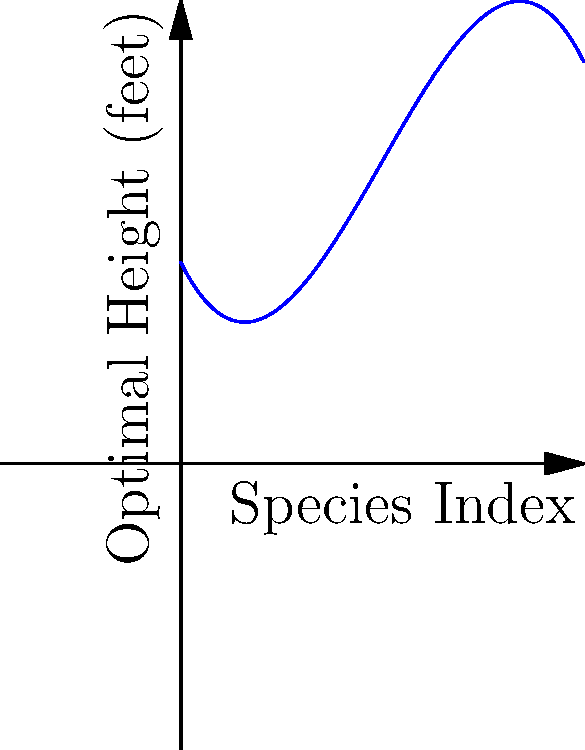The graph represents a polynomial function modeling the optimal height of birdhouses for different bird species, indexed from 0 to 10. Points A, B, and C correspond to specific species. Which species requires the tallest birdhouse, and what is its approximate optimal height? To determine which species requires the tallest birdhouse and its approximate height, we need to:

1. Identify the highest point on the curve.
2. Find the corresponding species index (x-coordinate).
3. Estimate the optimal height (y-coordinate) at that point.

Analyzing the graph:

1. The highest point on the curve appears to be around point B.
2. Point B corresponds to a species index of approximately 5.
3. The y-coordinate of point B is about 7 feet.

Therefore, the species with index 5 requires the tallest birdhouse, with an optimal height of approximately 7 feet.

This aligns with the conservationist's goal of promoting bird conservation by providing optimal habitats for various species.
Answer: Species index 5, approximately 7 feet tall 